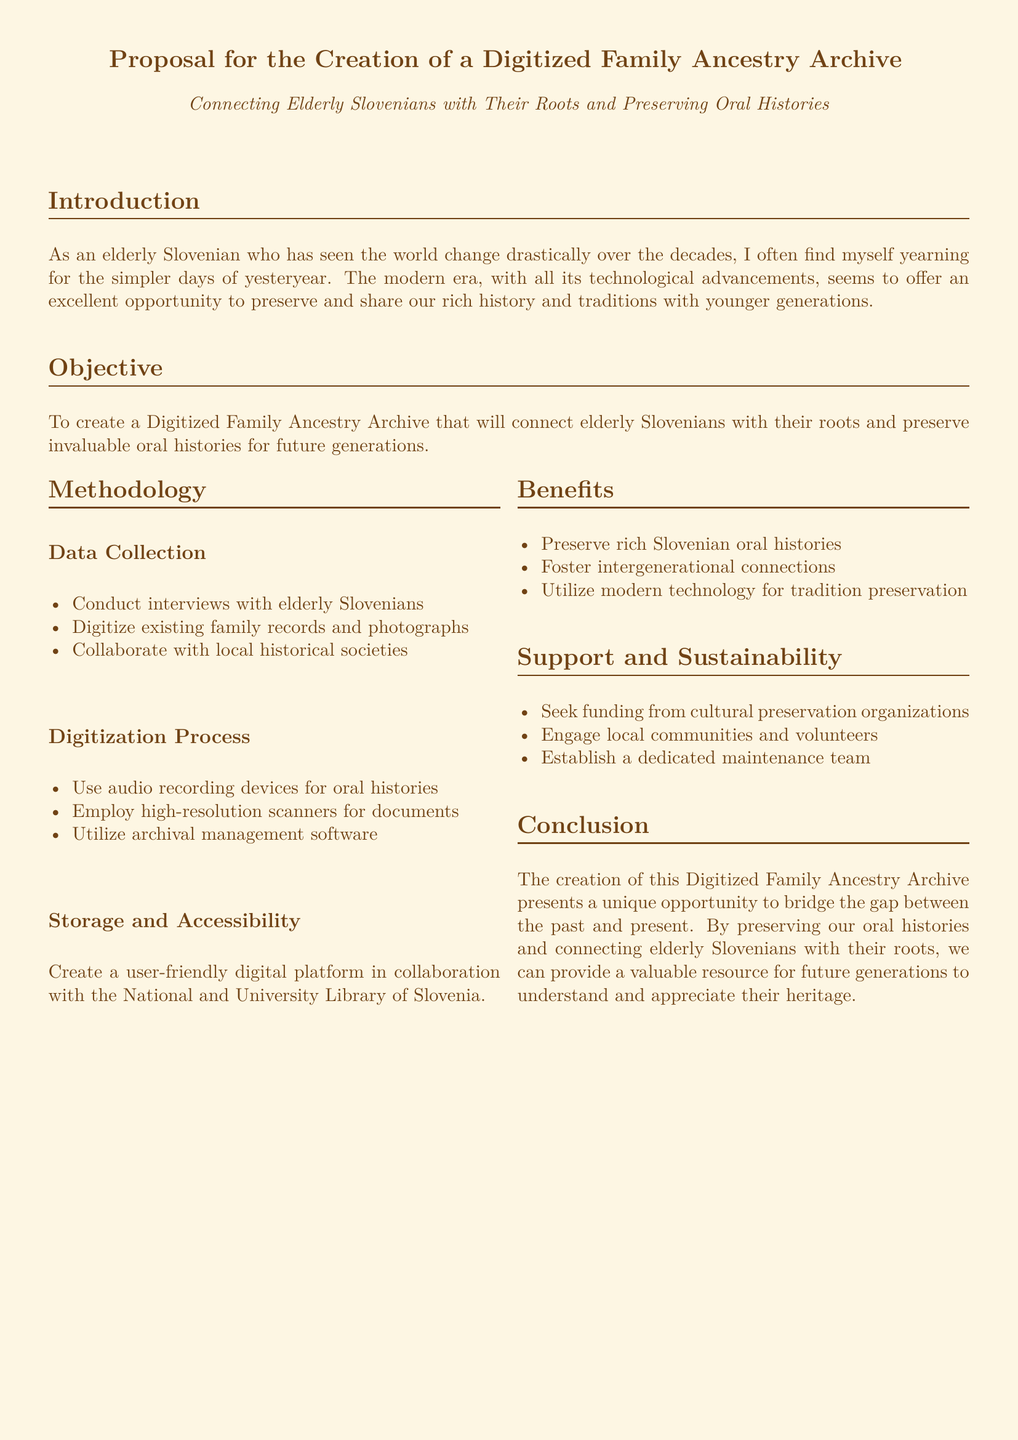What is the title of the proposal? The title of the proposal is stated clearly at the top of the document.
Answer: Proposal for the Creation of a Digitized Family Ancestry Archive What is the main objective of the proposal? The objective section outlines the primary goal of the initiative.
Answer: To connect elderly Slovenians with their roots and preserve invaluable oral histories for future generations Which organization is mentioned for collaboration on the digital platform? The storage and accessibility section mentions an important collaborator for creating the digital platform.
Answer: National and University Library of Slovenia What does the methodology include for data collection? The methodology outlines specific actions for collecting data, including interviews and collaboration.
Answer: Conduct interviews with elderly Slovenians Name one benefit of the proposed archive. The benefits section lists several advantages of the proposal.
Answer: Preserve rich Slovenian oral histories What type of team is proposed for sustainability? The support and sustainability section specifies a type of team to be established for ongoing management.
Answer: Dedicated maintenance team How many subsections are under Methodology? The methodology section contains a specific number of subsections that detail the proposed processes.
Answer: Three 